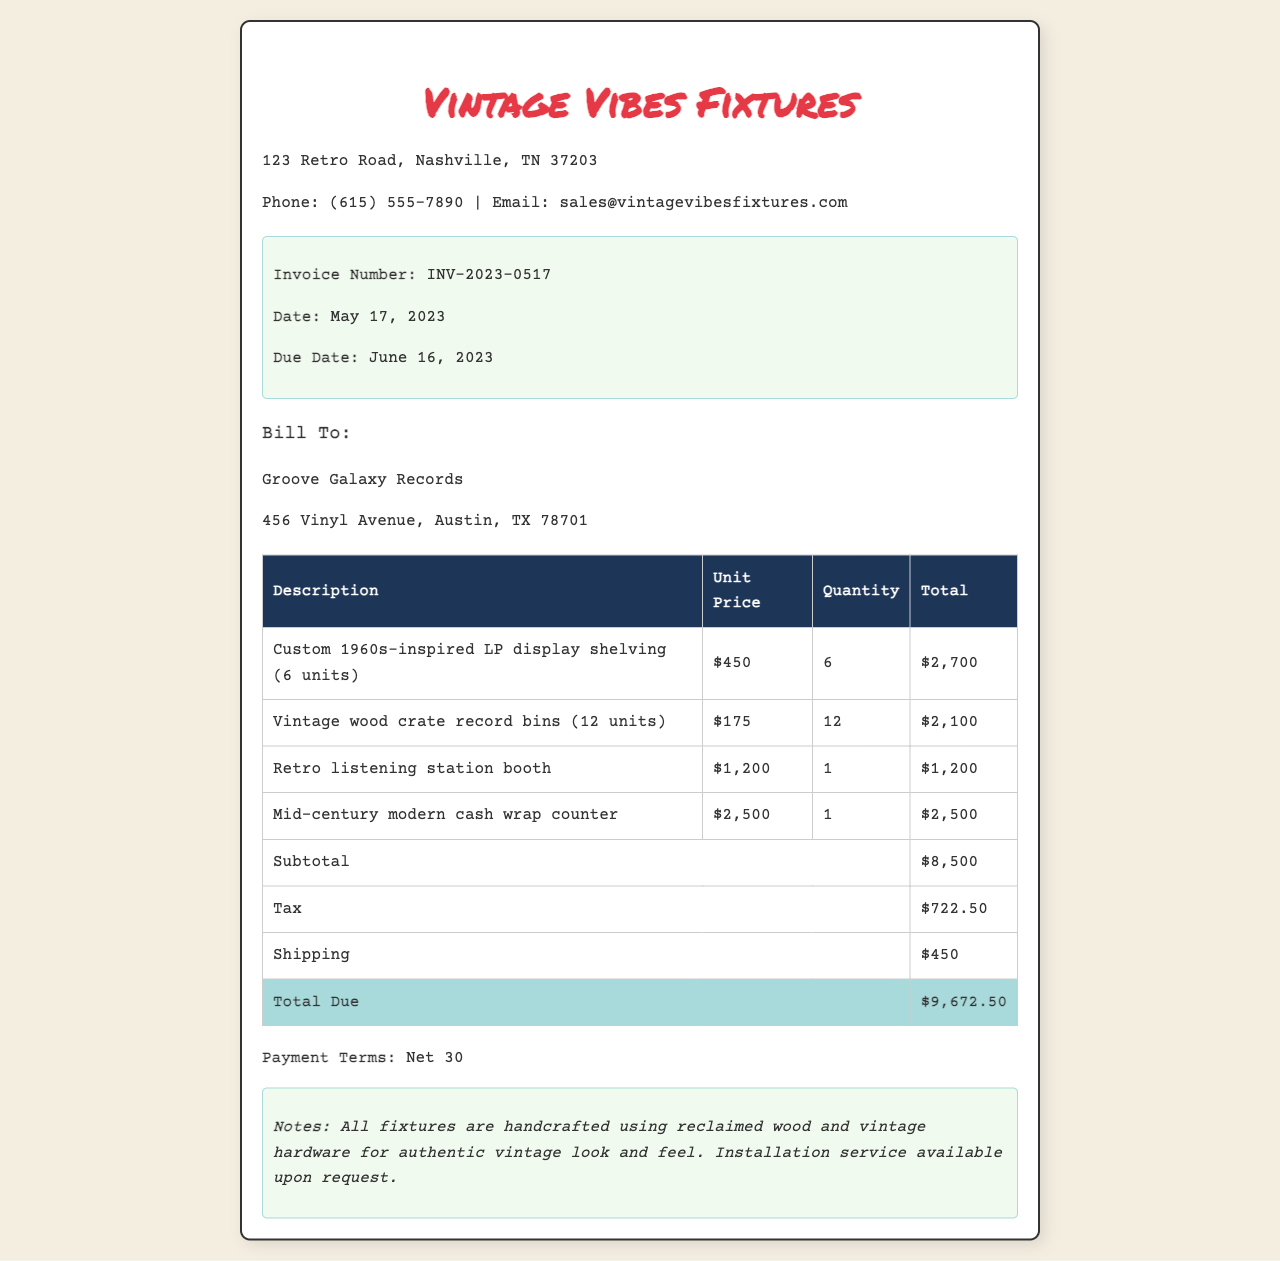What is the invoice number? The invoice number is specified in the invoice details section as a unique identifier for the document.
Answer: INV-2023-0517 What is the total due amount? The total due amount is calculated from the summary at the end of the invoice, which includes subtotal, tax, and shipping.
Answer: $9,672.50 How many vintage wood crate record bins were ordered? The quantity of vintage wood crate record bins is given in the table under the quantity column.
Answer: 12 What is the unit price of the custom 1960s-inspired LP display shelving? The unit price for this item is listed alongside its description in the table.
Answer: $450 What is the shipping cost? The shipping cost is indicated in the total summary section within the invoice.
Answer: $450 What is noted about the fixtures' materials? The notes section provides specific information about the materials used for the fixtures.
Answer: Reclaimed wood How many units of the retro listening station booth were ordered? The quantity is specified in the invoice table under the quantity column for that item.
Answer: 1 What is the due date for the invoice? The due date is explicitly mentioned in the invoice details section of the document.
Answer: June 16, 2023 What client is billed for these fixtures? The bill to section of the invoice mentions the name of the client being billed for the fixtures.
Answer: Groove Galaxy Records 